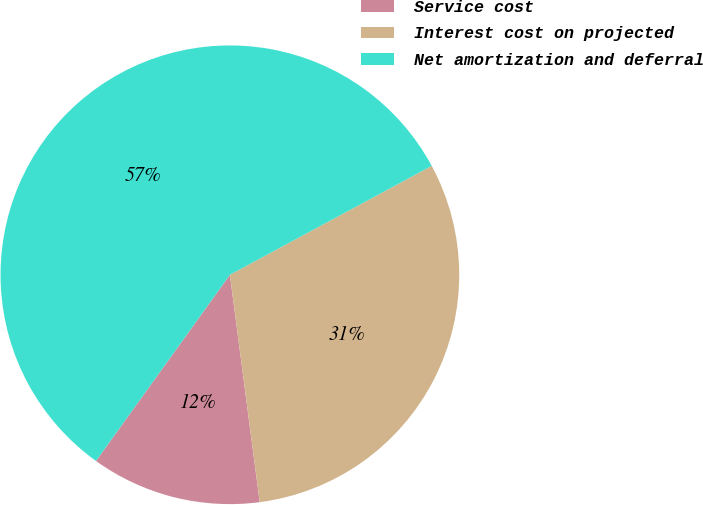Convert chart. <chart><loc_0><loc_0><loc_500><loc_500><pie_chart><fcel>Service cost<fcel>Interest cost on projected<fcel>Net amortization and deferral<nl><fcel>12.0%<fcel>30.8%<fcel>57.2%<nl></chart> 